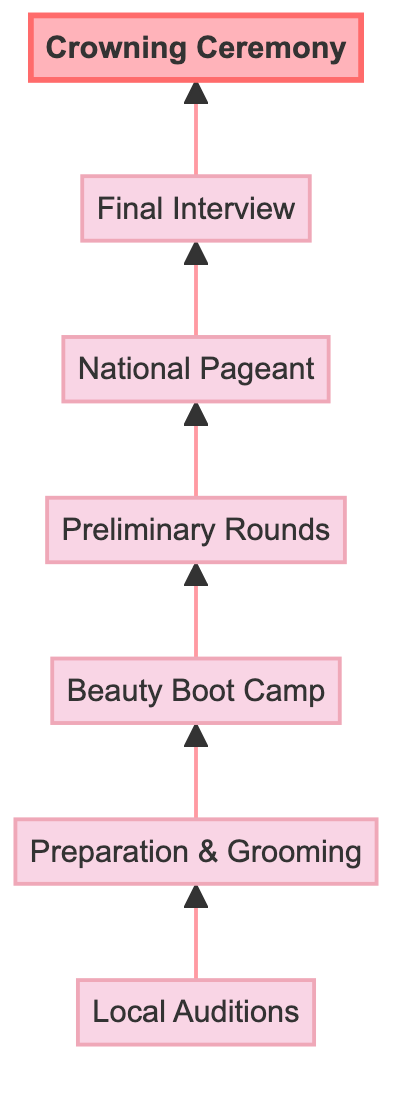What is the first step in the journey of a beauty pageant contestant? The diagram shows that the journey begins with "Local Auditions," which is the first node in the flowchart.
Answer: Local Auditions Which step follows "Beauty Boot Camp"? In the flowchart, "Beauty Boot Camp" is directly linked to the next step, which is "Preliminary Rounds."
Answer: Preliminary Rounds How many main stages are there in the contestant's journey? Counting the nodes in the flowchart, there are a total of 7 main stages: Local Auditions, Preparation & Grooming, Beauty Boot Camp, Preliminary Rounds, National Pageant, Final Interview, and Crowning Ceremony.
Answer: 7 What is the final stage of the contestant's journey? The diagram indicates that the last step, at the top of the flowchart, is the "Crowning Ceremony."
Answer: Crowning Ceremony Which two steps are directly connected before the "Final Interview"? The flowchart shows the sequence from "National Pageant" to "Final Interview," indicating that these two stages are directly connected before reaching the final interview stage.
Answer: National Pageant and Final Interview What type of training do contestants receive at Beauty Boot Camp? The description states that contestants receive professional training in makeup, styling, and etiquette during "Beauty Boot Camp."
Answer: Makeup, styling, and etiquette What is the main purpose of the “Final Interview”? In the diagram, it mentions that top finalists face a rigorous interview round, implying the questioning of challenging topics for assessment.
Answer: Rigorous interview What happens during the "Preliminary Rounds"? According to the flowchart, contestants showcase their skills in swimsuit, evening gown, and interview segments during the "Preliminary Rounds."
Answer: Showcase skills in swimsuit, evening gown, and interview segments What kind of event is the "National Pageant"? The flowchart describes the "National Pageant" as a competition that is often televised and features special guest judges, indicating its significant public and professional recognition.
Answer: Televised competition with guest judges 